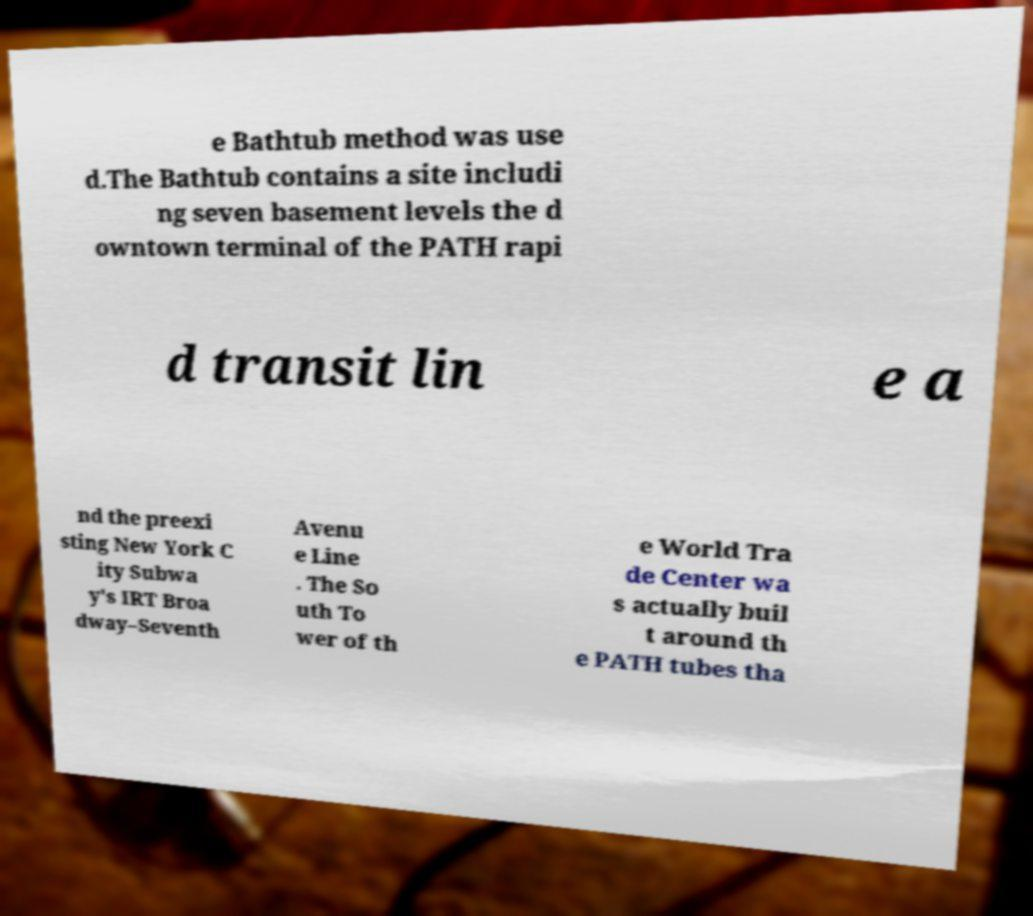Can you accurately transcribe the text from the provided image for me? e Bathtub method was use d.The Bathtub contains a site includi ng seven basement levels the d owntown terminal of the PATH rapi d transit lin e a nd the preexi sting New York C ity Subwa y's IRT Broa dway–Seventh Avenu e Line . The So uth To wer of th e World Tra de Center wa s actually buil t around th e PATH tubes tha 